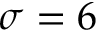Convert formula to latex. <formula><loc_0><loc_0><loc_500><loc_500>\sigma = 6</formula> 